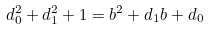Convert formula to latex. <formula><loc_0><loc_0><loc_500><loc_500>d _ { 0 } ^ { 2 } + d _ { 1 } ^ { 2 } + 1 = b ^ { 2 } + d _ { 1 } b + d _ { 0 }</formula> 